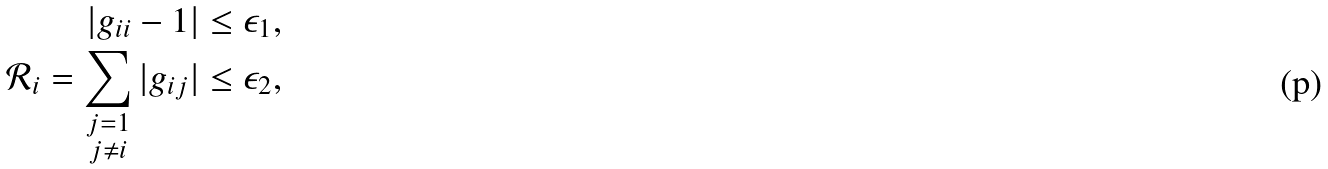Convert formula to latex. <formula><loc_0><loc_0><loc_500><loc_500>| g _ { i i } - 1 | \leq \epsilon _ { 1 } , \\ \mathcal { R } _ { i } = \sum _ { \substack { j = 1 \\ j \neq i } } { | g _ { i j } | } \leq \epsilon _ { 2 } ,</formula> 